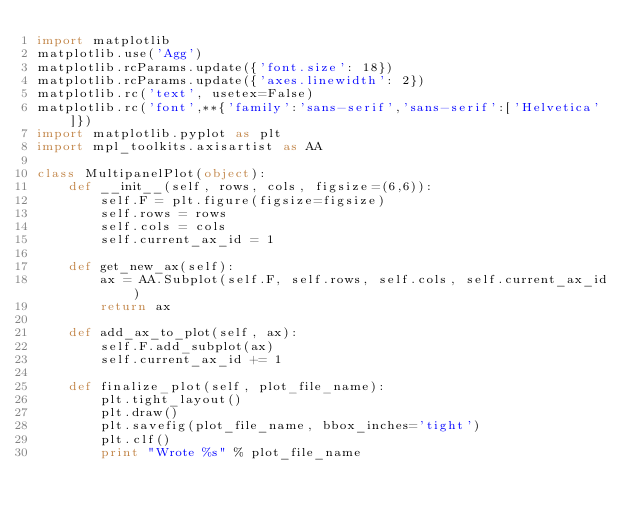<code> <loc_0><loc_0><loc_500><loc_500><_Python_>import matplotlib
matplotlib.use('Agg')
matplotlib.rcParams.update({'font.size': 18})
matplotlib.rcParams.update({'axes.linewidth': 2})
matplotlib.rc('text', usetex=False)
matplotlib.rc('font',**{'family':'sans-serif','sans-serif':['Helvetica']})
import matplotlib.pyplot as plt
import mpl_toolkits.axisartist as AA

class MultipanelPlot(object):
    def __init__(self, rows, cols, figsize=(6,6)):
        self.F = plt.figure(figsize=figsize)
        self.rows = rows
        self.cols = cols
        self.current_ax_id = 1

    def get_new_ax(self):
        ax = AA.Subplot(self.F, self.rows, self.cols, self.current_ax_id)
        return ax

    def add_ax_to_plot(self, ax):
        self.F.add_subplot(ax)
        self.current_ax_id += 1

    def finalize_plot(self, plot_file_name):
        plt.tight_layout()
        plt.draw()
        plt.savefig(plot_file_name, bbox_inches='tight')
        plt.clf()
        print "Wrote %s" % plot_file_name
</code> 